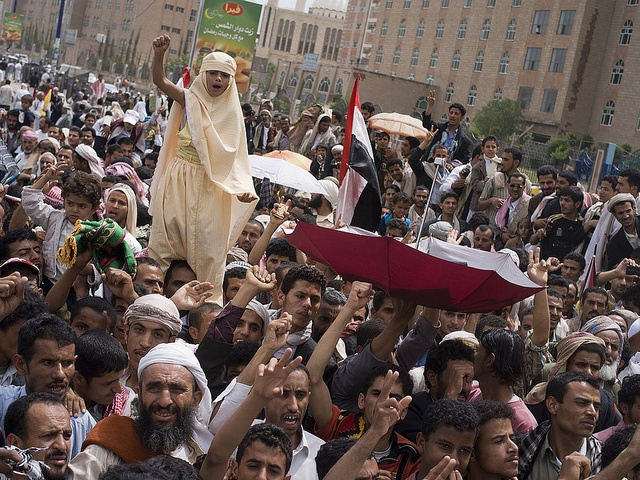Describe the objects in this image and their specific colors. I can see people in gray, black, maroon, and darkgray tones, people in gray and tan tones, umbrella in gray, maroon, black, darkgray, and lightgray tones, people in gray, black, maroon, and darkgray tones, and people in gray, black, maroon, and brown tones in this image. 